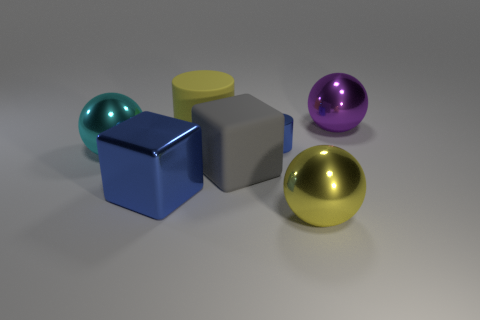Is there any other thing that has the same material as the big blue object?
Offer a very short reply. Yes. What is the material of the sphere that is the same color as the rubber cylinder?
Give a very brief answer. Metal. There is another rubber thing that is the same shape as the small blue thing; what color is it?
Offer a very short reply. Yellow. How many rubber objects are tiny objects or yellow cylinders?
Your answer should be compact. 1. There is a big metallic sphere behind the big sphere on the left side of the blue cylinder; are there any large purple metallic objects that are left of it?
Ensure brevity in your answer.  No. What is the color of the rubber block?
Keep it short and to the point. Gray. There is a thing that is behind the big yellow rubber thing; does it have the same shape as the cyan object?
Offer a terse response. Yes. What number of things are large cylinders or large metallic objects in front of the big purple metal object?
Offer a very short reply. 4. Does the small blue cylinder to the right of the big blue metallic block have the same material as the large yellow cylinder?
Your response must be concise. No. Is there any other thing that is the same size as the blue cylinder?
Make the answer very short. No. 